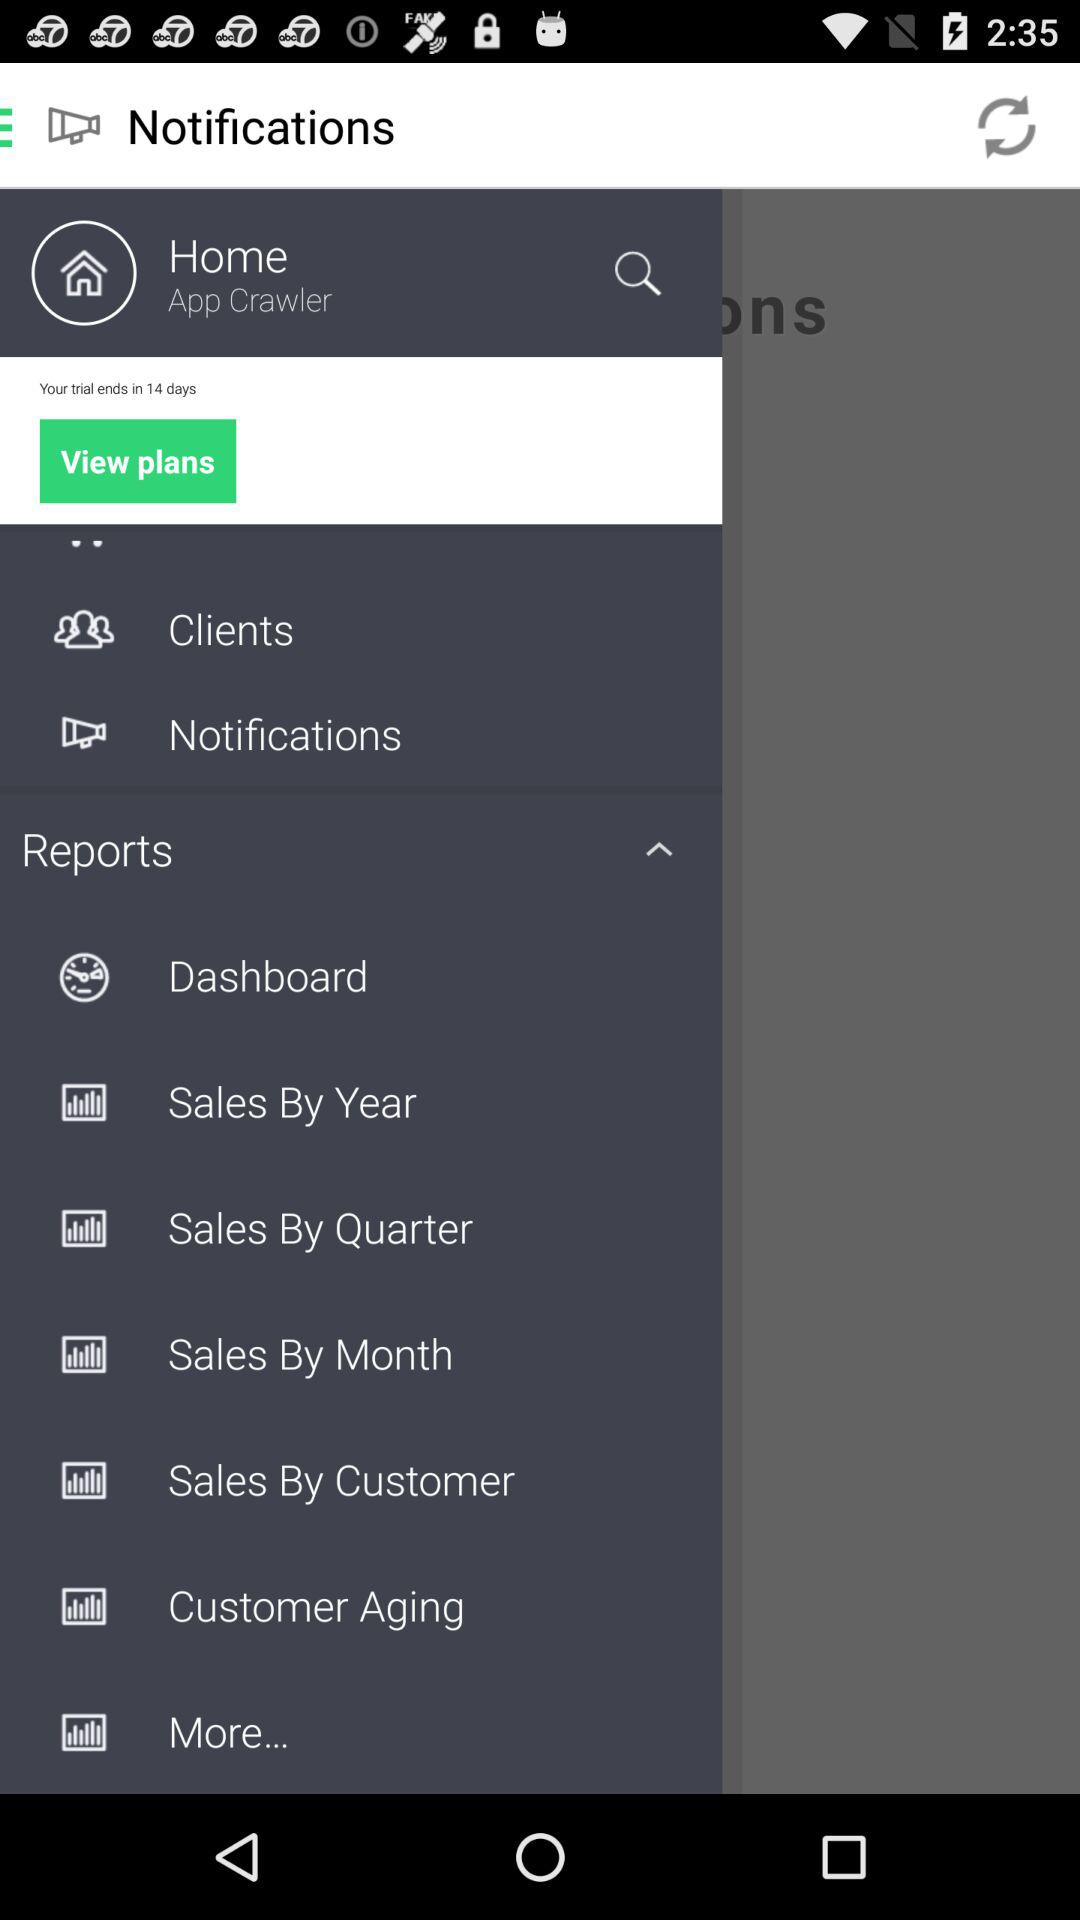In how many days will the trial end? The trial will end in 14 days. 